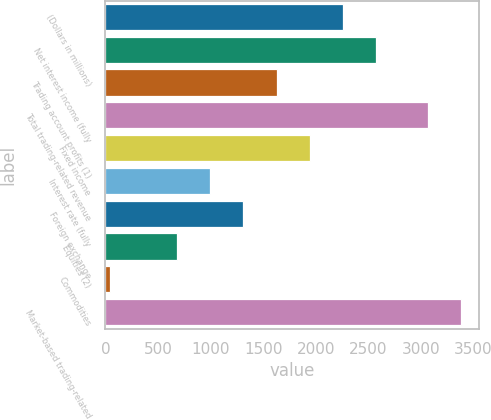Convert chart to OTSL. <chart><loc_0><loc_0><loc_500><loc_500><bar_chart><fcel>(Dollars in millions)<fcel>Net interest income (fully<fcel>Trading account profits (1)<fcel>Total trading-related revenue<fcel>Fixed income<fcel>Interest rate (fully<fcel>Foreign exchange<fcel>Equities (2)<fcel>Commodities<fcel>Market-based trading-related<nl><fcel>2261.2<fcel>2577.8<fcel>1628<fcel>3067<fcel>1944.6<fcel>994.8<fcel>1311.4<fcel>678.2<fcel>45<fcel>3383.6<nl></chart> 